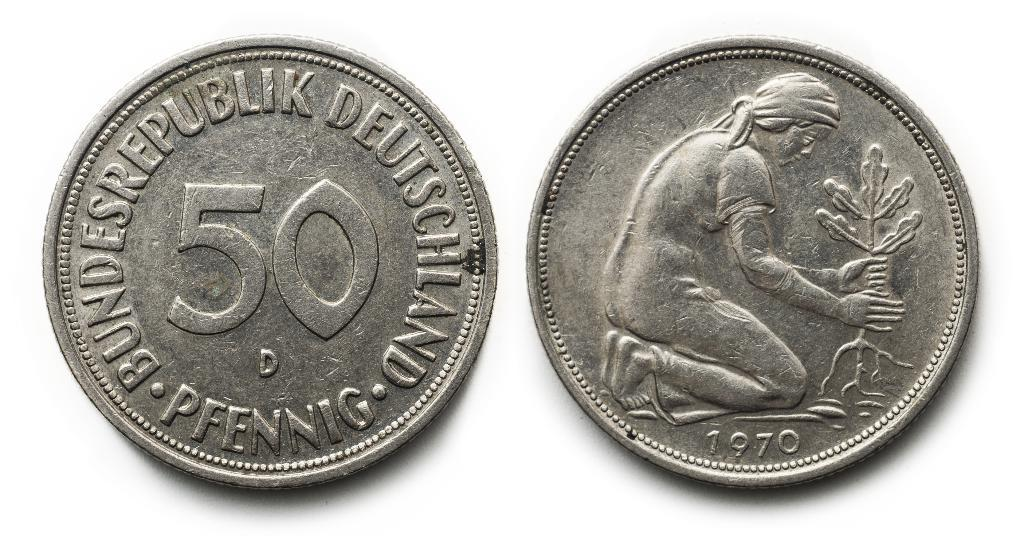<image>
Describe the image concisely. Two coins made in 1970 and called a pfennig 